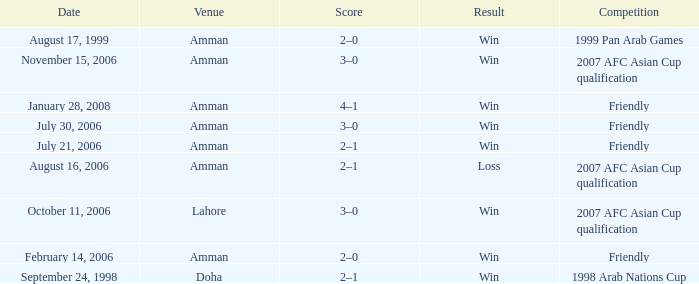Which competition took place on October 11, 2006? 2007 AFC Asian Cup qualification. Can you parse all the data within this table? {'header': ['Date', 'Venue', 'Score', 'Result', 'Competition'], 'rows': [['August 17, 1999', 'Amman', '2–0', 'Win', '1999 Pan Arab Games'], ['November 15, 2006', 'Amman', '3–0', 'Win', '2007 AFC Asian Cup qualification'], ['January 28, 2008', 'Amman', '4–1', 'Win', 'Friendly'], ['July 30, 2006', 'Amman', '3–0', 'Win', 'Friendly'], ['July 21, 2006', 'Amman', '2–1', 'Win', 'Friendly'], ['August 16, 2006', 'Amman', '2–1', 'Loss', '2007 AFC Asian Cup qualification'], ['October 11, 2006', 'Lahore', '3–0', 'Win', '2007 AFC Asian Cup qualification'], ['February 14, 2006', 'Amman', '2–0', 'Win', 'Friendly'], ['September 24, 1998', 'Doha', '2–1', 'Win', '1998 Arab Nations Cup']]} 